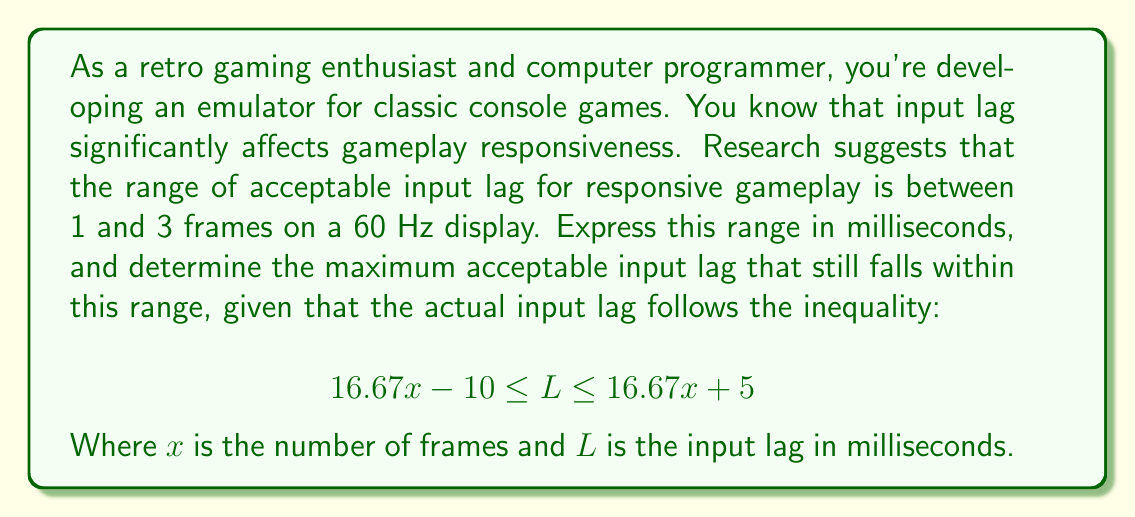Can you solve this math problem? Let's approach this step-by-step:

1. Convert the frame range to milliseconds:
   - 1 frame at 60 Hz: $\frac{1000}{60} \approx 16.67$ ms
   - 3 frames at 60 Hz: $3 \times \frac{1000}{60} \approx 50$ ms

   So, the acceptable range is approximately 16.67 ms to 50 ms.

2. Use the given inequality to find the maximum acceptable input lag:
   $$ 16.67x - 10 \leq L \leq 16.67x + 5 $$

3. We want to find the maximum value of $L$ that still falls within the acceptable range. This occurs when $x = 3$ (3 frames).

4. Substitute $x = 3$ into the right side of the inequality:
   $$ L \leq 16.67(3) + 5 $$
   $$ L \leq 50.01 + 5 $$
   $$ L \leq 55.01 $$

5. The maximum acceptable input lag is the smaller of 55.01 ms (from the inequality) and 50 ms (from the acceptable range).

Therefore, the maximum acceptable input lag is 50 ms.
Answer: The range of acceptable input lag is approximately 16.67 ms to 50 ms, and the maximum acceptable input lag that falls within this range is 50 ms. 